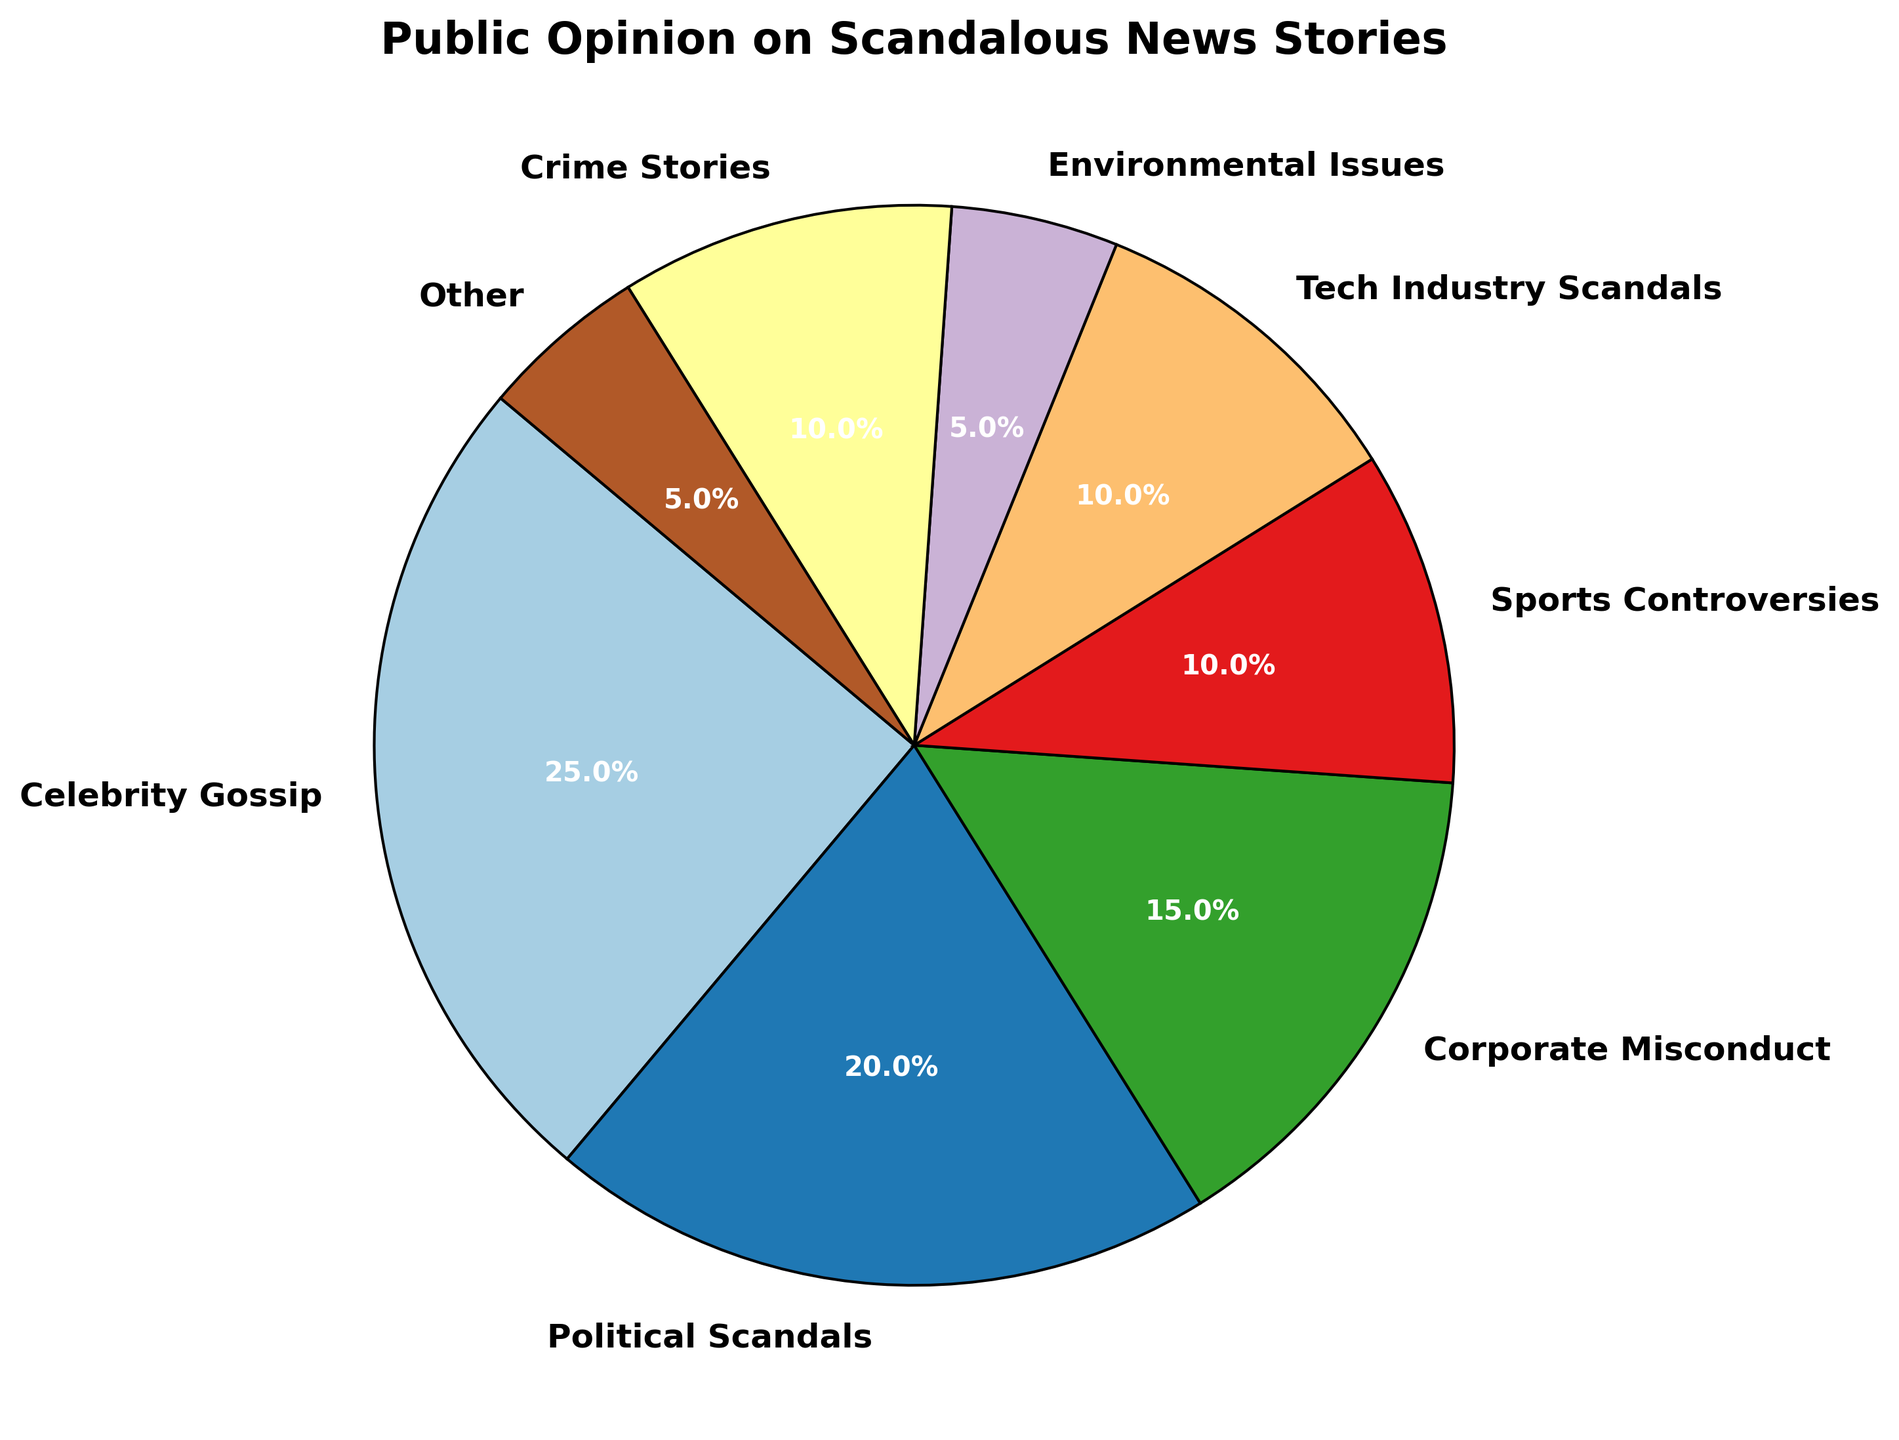What percentage of the pie chart is occupied by 'Political Scandals' and 'Corporate Misconduct' combined? To determine this, add the percentage of 'Political Scandals' (20%) to 'Corporate Misconduct' (15%). 20% + 15% = 35%
Answer: 35% Which category has the smallest percentage and what is it? To find the category with the smallest percentage, look at all the slices in the pie chart and identify the one with the lowest value. The 'Environmental Issues' and 'Other' categories both have the smallest percentage at 5%.
Answer: Environmental Issues and Other, 5% How does the percentage of 'Celebrity Gossip' compare to 'Sports Controversies'? 'Celebrity Gossip' occupies 25% of the pie chart, while 'Sports Controversies' occupies 10%. Compare these two values: 25% is greater than 10%.
Answer: Celebrity Gossip has a higher percentage What is the combined percentage of all categories that are 10% or less? Sum the percentages of the categories that are 10% or less: 'Sports Controversies' (10%), 'Tech Industry Scandals' (10%), 'Crime Stories' (10%), 'Environmental Issues' (5%), and 'Other' (5%). 10% + 10% + 10% + 5% + 5% = 40%
Answer: 40% Which category is represented by the largest slice of the pie chart and what is its percentage? Identify the largest slice in the pie chart and read off its percentage. The largest slice belongs to 'Celebrity Gossip', which occupies 25% of the pie chart.
Answer: Celebrity Gossip, 25% What is the difference in percentage between 'Tech Industry Scandals' and 'Crime Stories'? Subtract the percentage of 'Tech Industry Scandals' (10%) from 'Crime Stories' (10%). 10% - 10% = 0%.
Answer: 0% What is the total percentage occupied by all categories except 'Celebrity Gossip'? Subtract the percentage of 'Celebrity Gossip' (25%) from the total (100%). 100% - 25% = 75%.
Answer: 75% If 'Political Scandals' and 'Corporate Misconduct' were combined into one category, how would its percentage compare to 'Celebrity Gossip'? First combine the percentages of 'Political Scandals' (20%) and 'Corporate Misconduct' (15%): 20% + 15% = 35%. Compare this to 'Celebrity Gossip' which is 25%. 35% is greater than 25%.
Answer: Higher Which two categories combined make up 30% of the pie chart? Look for two categories whose summed percentages equal 30%. 'Political Scandals' (20%) and 'Crime Stories' (10%) combined make 30%.
Answer: Political Scandals and Crime Stories 